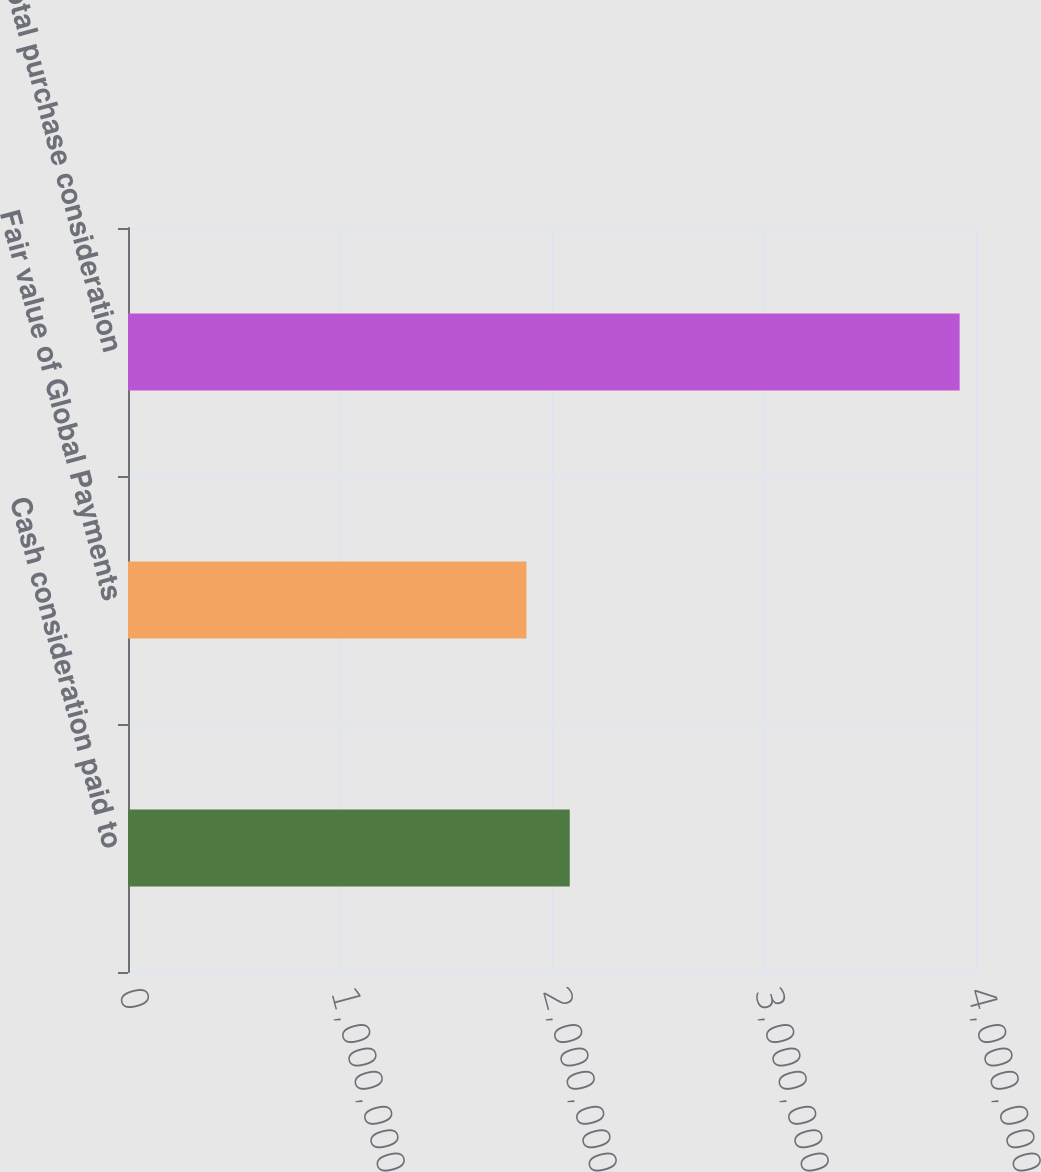Convert chart to OTSL. <chart><loc_0><loc_0><loc_500><loc_500><bar_chart><fcel>Cash consideration paid to<fcel>Fair value of Global Payments<fcel>Total purchase consideration<nl><fcel>2.08379e+06<fcel>1.87946e+06<fcel>3.92282e+06<nl></chart> 